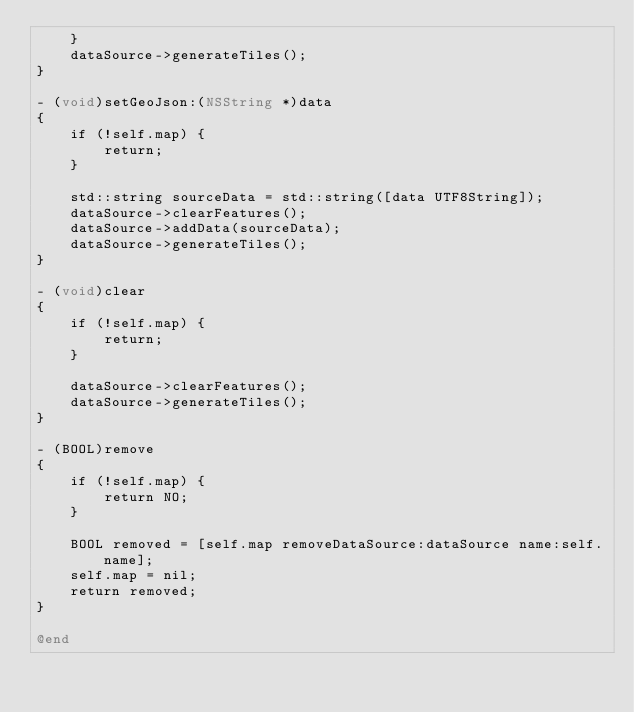Convert code to text. <code><loc_0><loc_0><loc_500><loc_500><_ObjectiveC_>    }
    dataSource->generateTiles();
}

- (void)setGeoJson:(NSString *)data
{
    if (!self.map) {
        return;
    }

    std::string sourceData = std::string([data UTF8String]);
    dataSource->clearFeatures();
    dataSource->addData(sourceData);
    dataSource->generateTiles();
}

- (void)clear
{
    if (!self.map) {
        return;
    }

    dataSource->clearFeatures();
    dataSource->generateTiles();
}

- (BOOL)remove
{
    if (!self.map) {
        return NO;
    }

    BOOL removed = [self.map removeDataSource:dataSource name:self.name];
    self.map = nil;
    return removed;
}

@end
</code> 